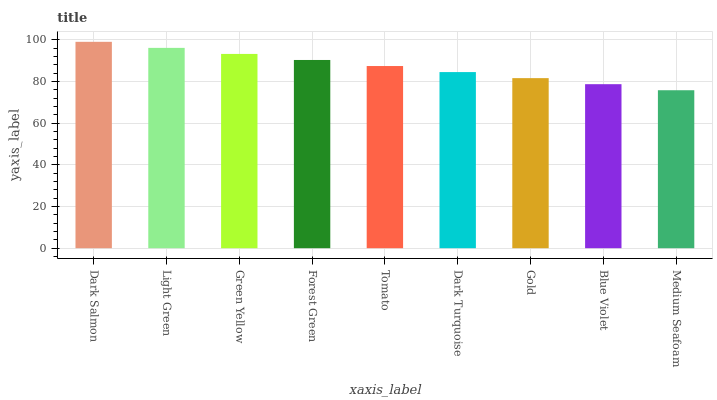Is Medium Seafoam the minimum?
Answer yes or no. Yes. Is Dark Salmon the maximum?
Answer yes or no. Yes. Is Light Green the minimum?
Answer yes or no. No. Is Light Green the maximum?
Answer yes or no. No. Is Dark Salmon greater than Light Green?
Answer yes or no. Yes. Is Light Green less than Dark Salmon?
Answer yes or no. Yes. Is Light Green greater than Dark Salmon?
Answer yes or no. No. Is Dark Salmon less than Light Green?
Answer yes or no. No. Is Tomato the high median?
Answer yes or no. Yes. Is Tomato the low median?
Answer yes or no. Yes. Is Gold the high median?
Answer yes or no. No. Is Green Yellow the low median?
Answer yes or no. No. 